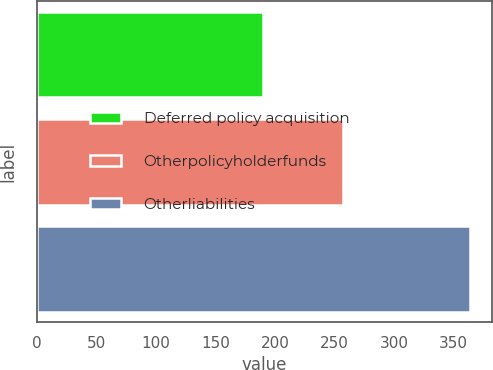Convert chart. <chart><loc_0><loc_0><loc_500><loc_500><bar_chart><fcel>Deferred policy acquisition<fcel>Otherpolicyholderfunds<fcel>Otherliabilities<nl><fcel>190<fcel>257<fcel>364<nl></chart> 